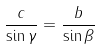Convert formula to latex. <formula><loc_0><loc_0><loc_500><loc_500>\frac { c } { \sin \gamma } = \frac { b } { \sin \beta }</formula> 